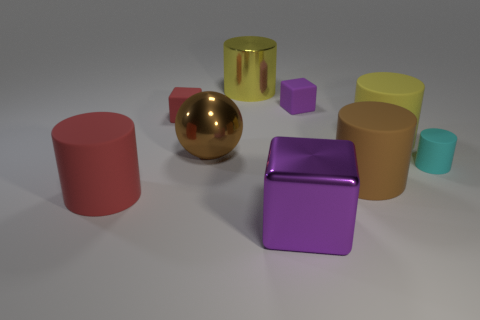Do the red cylinder and the purple matte object have the same size?
Provide a succinct answer. No. Is there a big ball on the right side of the cylinder that is to the right of the large yellow cylinder to the right of the big purple metal block?
Provide a succinct answer. No. There is a red thing that is the same shape as the purple shiny object; what is it made of?
Give a very brief answer. Rubber. What color is the metal object that is in front of the red rubber cylinder?
Ensure brevity in your answer.  Purple. The purple shiny object is what size?
Give a very brief answer. Large. Do the brown rubber cylinder and the yellow thing on the right side of the small purple rubber thing have the same size?
Keep it short and to the point. Yes. There is a tiny matte object that is right of the yellow cylinder that is in front of the purple thing that is behind the small cyan rubber thing; what color is it?
Provide a short and direct response. Cyan. Is the large yellow object that is behind the large yellow rubber thing made of the same material as the small cylinder?
Offer a terse response. No. How many other objects are the same material as the small purple cube?
Ensure brevity in your answer.  5. What material is the brown sphere that is the same size as the yellow matte object?
Offer a terse response. Metal. 